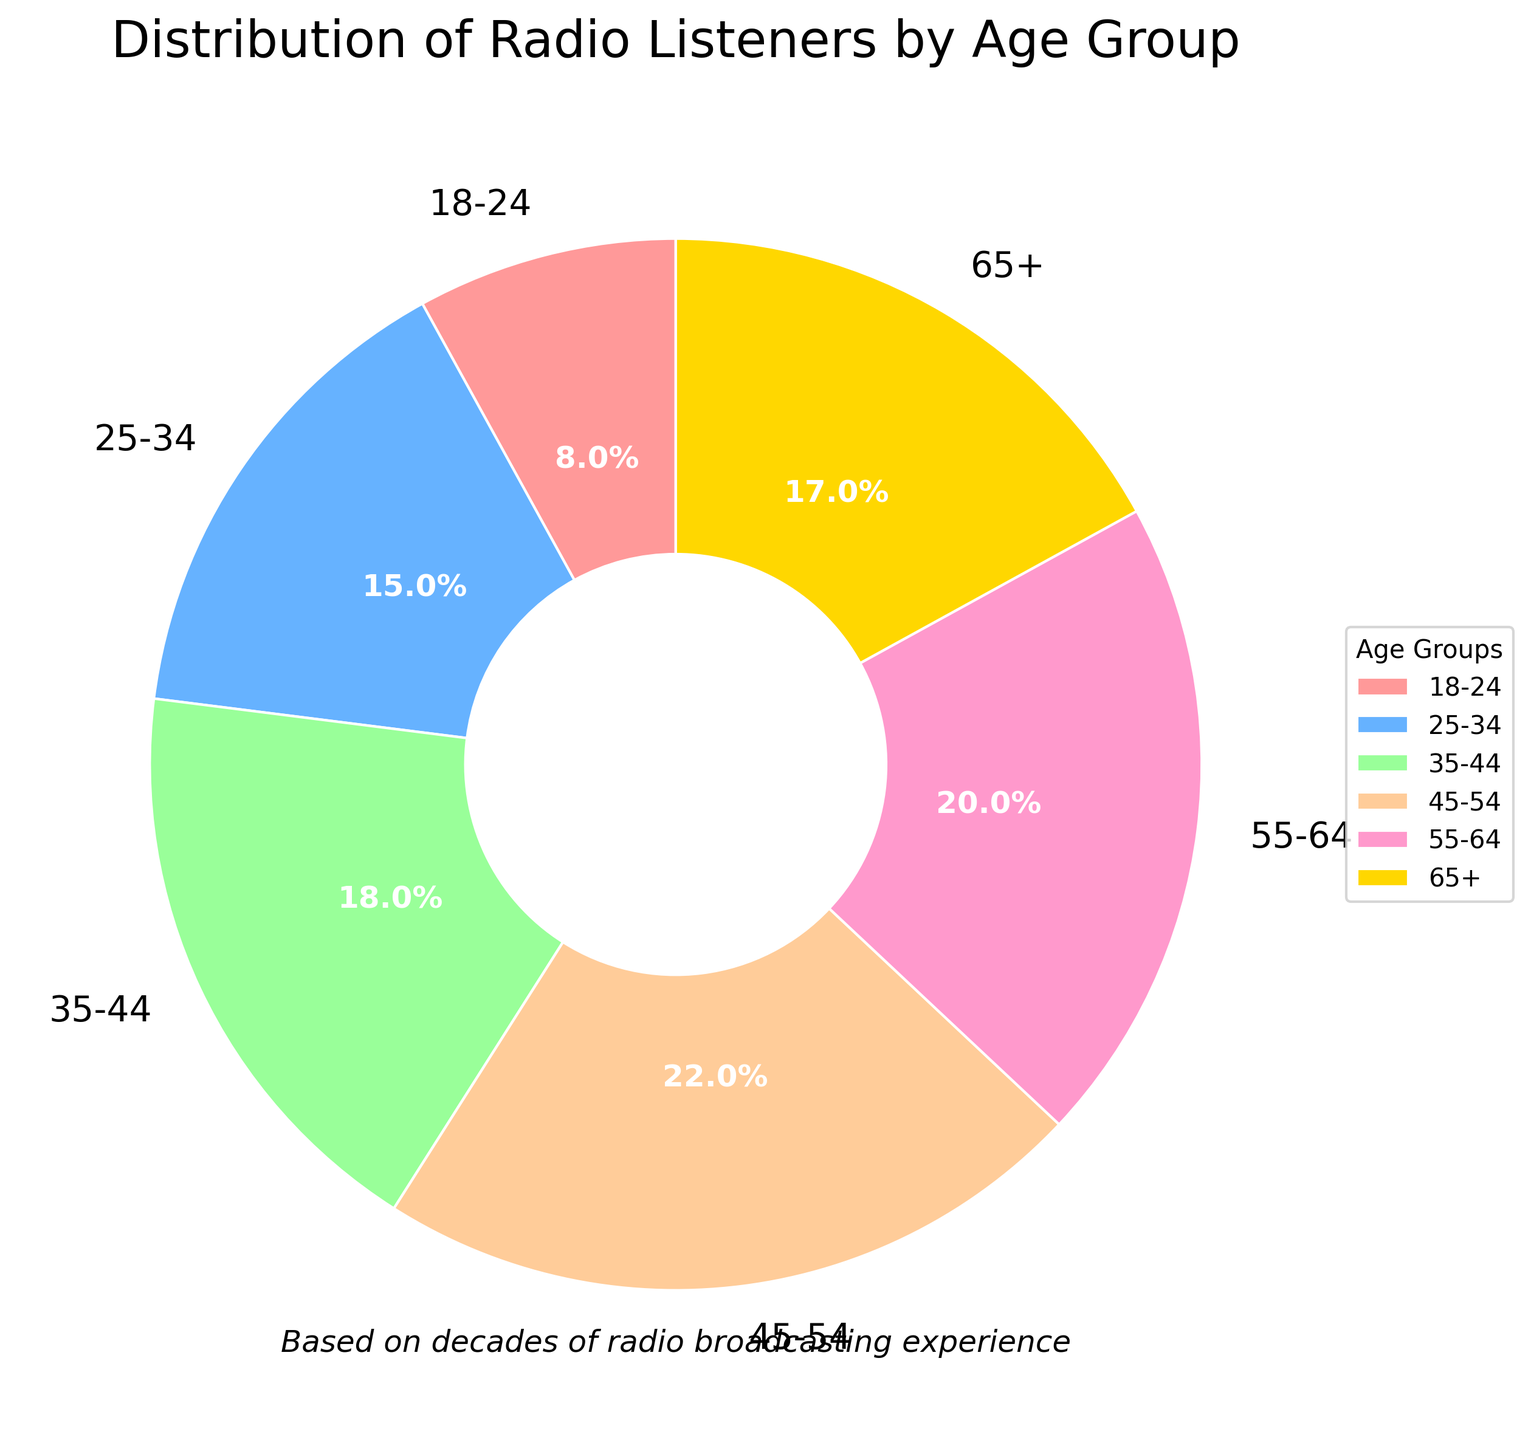What age group has the largest percentage of radio listeners? The chart shows the percentage of each age group. The group 45-54 has the highest value at 22%, making it the largest percentage of radio listeners.
Answer: 45-54 Which age group has the smallest percentage of radio listeners? By inspecting the chart, the age group 18-24 has the smallest percentage at 8%.
Answer: 18-24 What is the combined percentage of radio listeners aged 35-44 and 55-64? Adding the percentages of the 35-44 group (18%) and the 55-64 group (20%) gives a combined percentage of 38%.
Answer: 38% Are there more radio listeners in the 25-34 age group or the 65+ age group? Comparing the percentages, the 25-34 age group has 15%, whereas the 65+ group has 17%. Therefore, the 65+ age group has more listeners.
Answer: 65+ Which age group has a percentage closest to 20%? By examining the chart, the 55-64 age group has a percentage of 20%, which is the closest to 20%.
Answer: 55-64 How much larger is the percentage of radio listeners in the 45-54 age group compared to the 18-24 age group? The difference between the 45-54 group (22%) and the 18-24 group (8%) is 14%.
Answer: 14% What is the total percentage of radio listeners for all age groups under 45? The percentages for the 18-24 (8%), 25-34 (15%), and 35-44 (18%) age groups sum up to 41%.
Answer: 41% What age group is represented by the green wedge in the pie chart? The green wedge in the pie chart represents the age group 35-44, which corresponds to 18% in the chart.
Answer: 35-44 Which age groups have a percentage that is higher than 15%? The age groups 35-44 (18%), 45-54 (22%), 55-64 (20%), and 65+ (17%) all have percentages higher than 15%.
Answer: 35-44, 45-54, 55-64, 65+ How many age groups have a percentage less than the 55-64 age group? The 55-64 age group has a percentage of 20%. The age groups with percentages less than 20% are 18-24 (8%), 25-34 (15%), 35-44 (18%), and 65+ (17%), making a total of four groups.
Answer: 4 